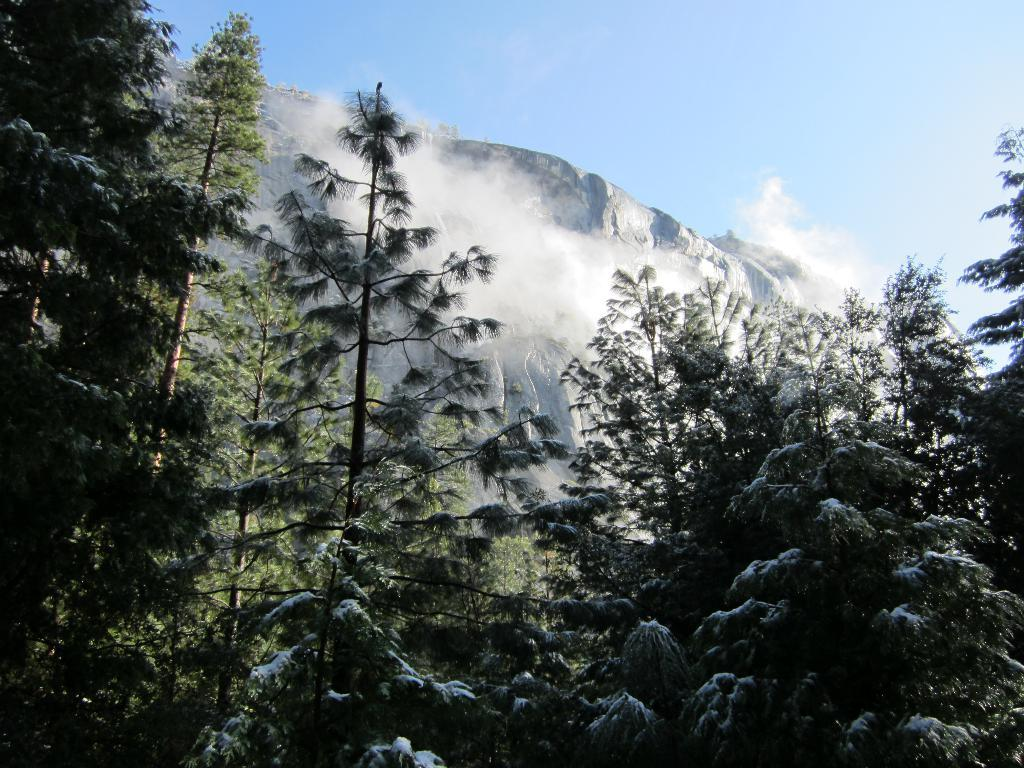What type of vegetation can be seen in the image? There are trees in the image. What else is visible in the image besides trees? There is smoke visible in the image. What geographical feature is present in the image? There is a hill in the image. What can be seen in the background of the image? The sky is visible in the background of the image. What type of grain is being used as bait for the chickens in the image? There are no chickens, grain, or bait present in the image. 